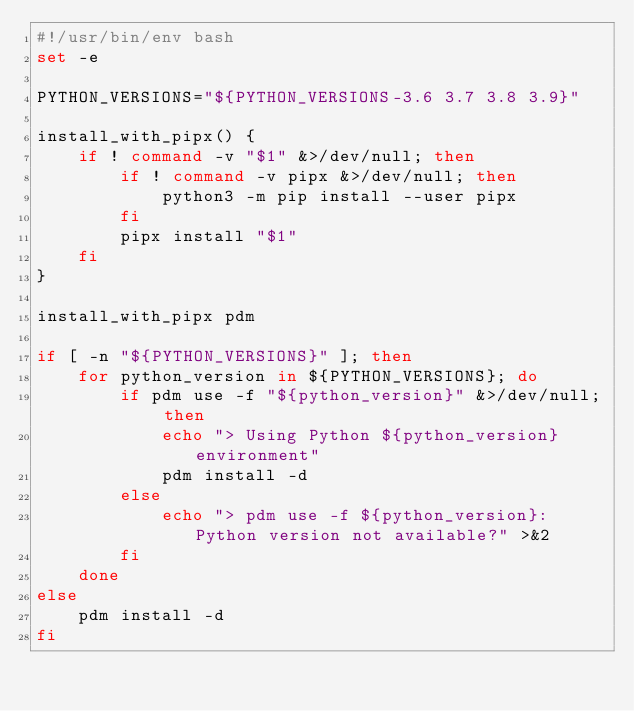Convert code to text. <code><loc_0><loc_0><loc_500><loc_500><_Bash_>#!/usr/bin/env bash
set -e

PYTHON_VERSIONS="${PYTHON_VERSIONS-3.6 3.7 3.8 3.9}"

install_with_pipx() {
    if ! command -v "$1" &>/dev/null; then
        if ! command -v pipx &>/dev/null; then
            python3 -m pip install --user pipx
        fi
        pipx install "$1"
    fi
}

install_with_pipx pdm

if [ -n "${PYTHON_VERSIONS}" ]; then
    for python_version in ${PYTHON_VERSIONS}; do
        if pdm use -f "${python_version}" &>/dev/null; then
            echo "> Using Python ${python_version} environment"
            pdm install -d
        else
            echo "> pdm use -f ${python_version}: Python version not available?" >&2
        fi
    done
else
    pdm install -d
fi</code> 